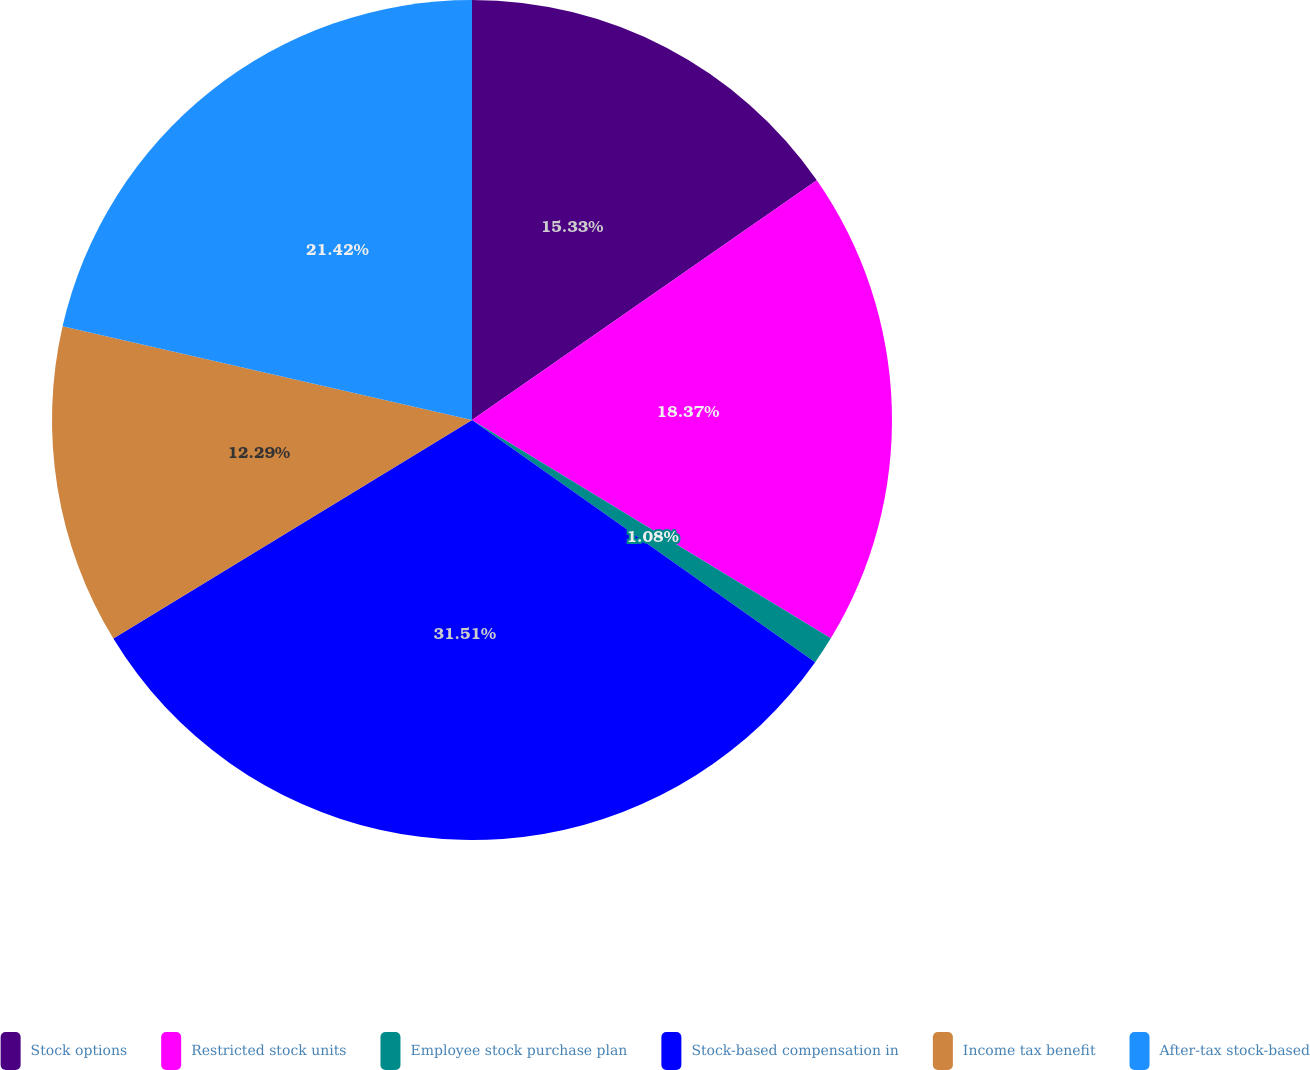Convert chart to OTSL. <chart><loc_0><loc_0><loc_500><loc_500><pie_chart><fcel>Stock options<fcel>Restricted stock units<fcel>Employee stock purchase plan<fcel>Stock-based compensation in<fcel>Income tax benefit<fcel>After-tax stock-based<nl><fcel>15.33%<fcel>18.37%<fcel>1.08%<fcel>31.51%<fcel>12.29%<fcel>21.42%<nl></chart> 